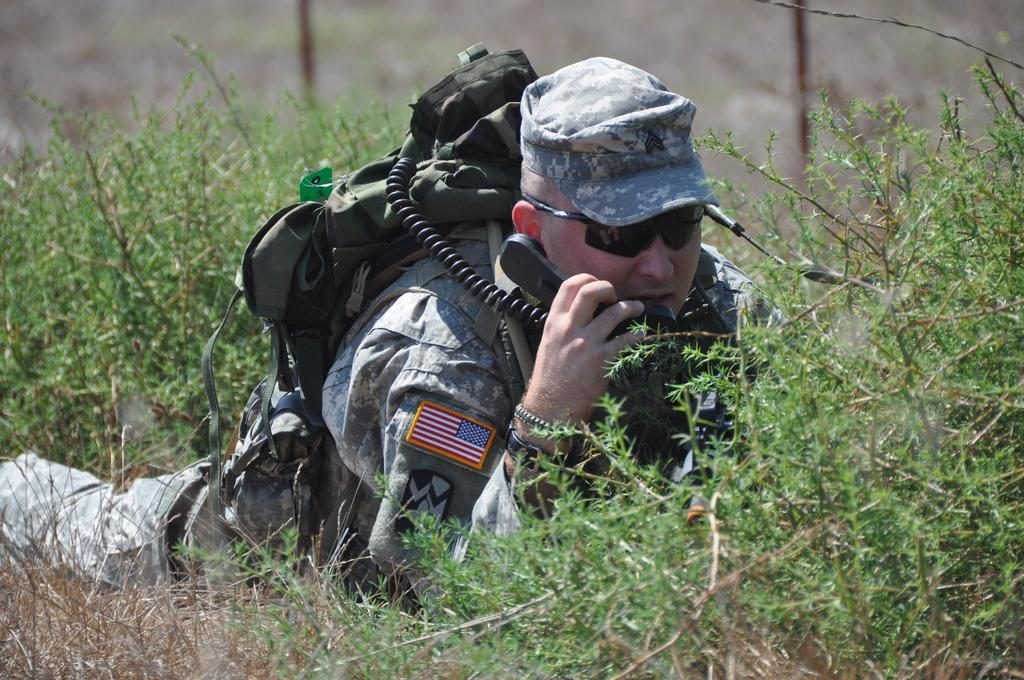What is the main subject of the image? There is a man in the image. What is the man doing in the image? The man is lying down. What is the man carrying in the image? The man is carrying a backpack. What is the man holding in the image? The man is holding a telephone. What type of vegetation is present at the bottom of the image? There are plants at the bottom of the image. How would you describe the background of the image? The background of the image is blurry. Can you tell me how many monkeys are in the group in the image? There are no monkeys or groups present in the image; it features a man lying down with a backpack and a telephone. What type of calculator is the man using in the image? There is no calculator present in the image; the man is holding a telephone. 